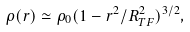<formula> <loc_0><loc_0><loc_500><loc_500>\rho ( r ) \simeq \rho _ { 0 } ( 1 - r ^ { 2 } / R ^ { 2 } _ { T F } ) ^ { 3 / 2 } ,</formula> 